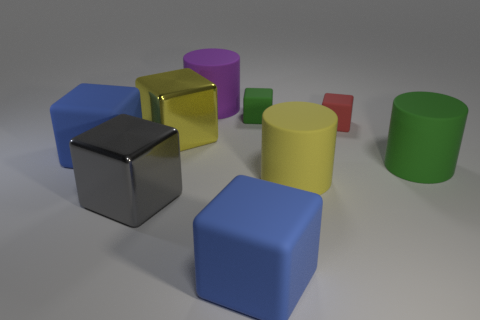There is a metal object that is in front of the large blue rubber object behind the big green object; what is its shape?
Give a very brief answer. Cube. There is a green rubber cylinder; is it the same size as the blue cube that is in front of the large yellow matte object?
Offer a terse response. Yes. How many tiny objects are either blue cylinders or purple cylinders?
Your answer should be very brief. 0. Are there more matte objects than small cubes?
Your answer should be compact. Yes. There is a large rubber thing behind the green object that is behind the tiny red cube; how many large purple cylinders are to the left of it?
Keep it short and to the point. 0. The gray metallic object is what shape?
Your response must be concise. Cube. What number of other objects are the same material as the large purple object?
Offer a very short reply. 6. Is the size of the yellow rubber cylinder the same as the purple cylinder?
Give a very brief answer. Yes. What is the shape of the large yellow thing that is behind the large yellow matte thing?
Your answer should be very brief. Cube. What is the color of the large rubber cylinder behind the cylinder that is right of the yellow rubber cylinder?
Make the answer very short. Purple. 